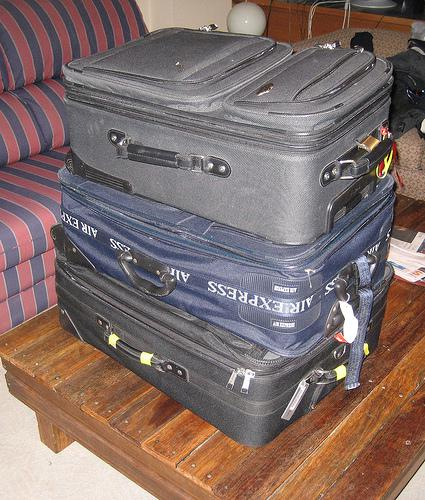Question: what is brown?
Choices:
A. Walls.
B. Couch.
C. Table.
D. Chair.
Answer with the letter. Answer: C Question: what is grey?
Choices:
A. Cabinet.
B. Top case.
C. Bottle.
D. Canister.
Answer with the letter. Answer: B Question: what is beige?
Choices:
A. Couch.
B. Table.
C. Walls.
D. Carpet.
Answer with the letter. Answer: D Question: how many suitcases?
Choices:
A. Two.
B. One.
C. Four.
D. Three.
Answer with the letter. Answer: D 